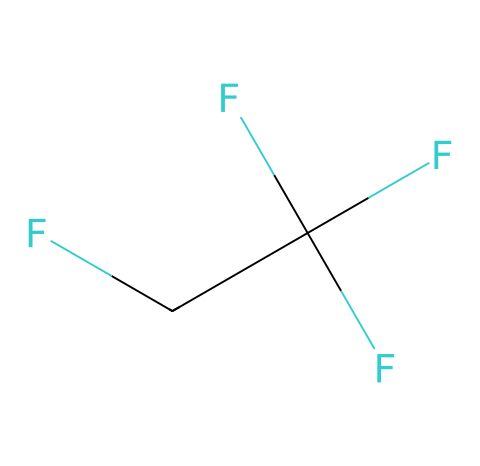What is the molecular formula of R-134a? The molecular formula can be derived from the SMILES representation, which shows the atoms present. In this case, there are 2 carbon atoms (C), 1 hydrogen atom (H), and 4 fluorine atoms (F), leading to the formula C2H2F4.
Answer: C2H2F4 How many fluorine atoms are in the R-134a structure? By analyzing the SMILES representation, we can count the number of fluorine (F) atoms present. The structure shows that there are 4 fluorine atoms attached to the carbon skeleton.
Answer: 4 What type of bonds are present in R-134a? The SMILES notation indicates single bonds between the carbon atoms and between carbon and fluorine atoms. Analyzing the structure confirms that R-134a consists entirely of single covalent bonds.
Answer: single bonds Which property of R-134a makes it suitable as a refrigerant? R-134a has a low boiling point and high latent heat of evaporation, properties that enable efficient heat exchange when used in refrigeration cycles.
Answer: low boiling point What is the significance of having a trifluoromethyl group in R-134a? The trifluoromethyl (CF3) group enhances the stability and lowers the environmental impact of chlorine-based refrigerants, making R-134a safer and more environmentally friendly.
Answer: stability How many total atoms are present in R-134a? By summing the different types of atoms in the molecular formula (2 carbons, 2 hydrogens, and 4 fluorines), we find a total of 8 atoms in the molecule.
Answer: 8 Is R-134a polar or nonpolar? The presence of highly electronegative fluorine atoms and their distribution around the carbon and hydrogen atoms creates a dipole moment in the molecule, indicating that R-134a is polar.
Answer: polar 